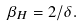<formula> <loc_0><loc_0><loc_500><loc_500>\beta _ { H } = 2 / \delta .</formula> 